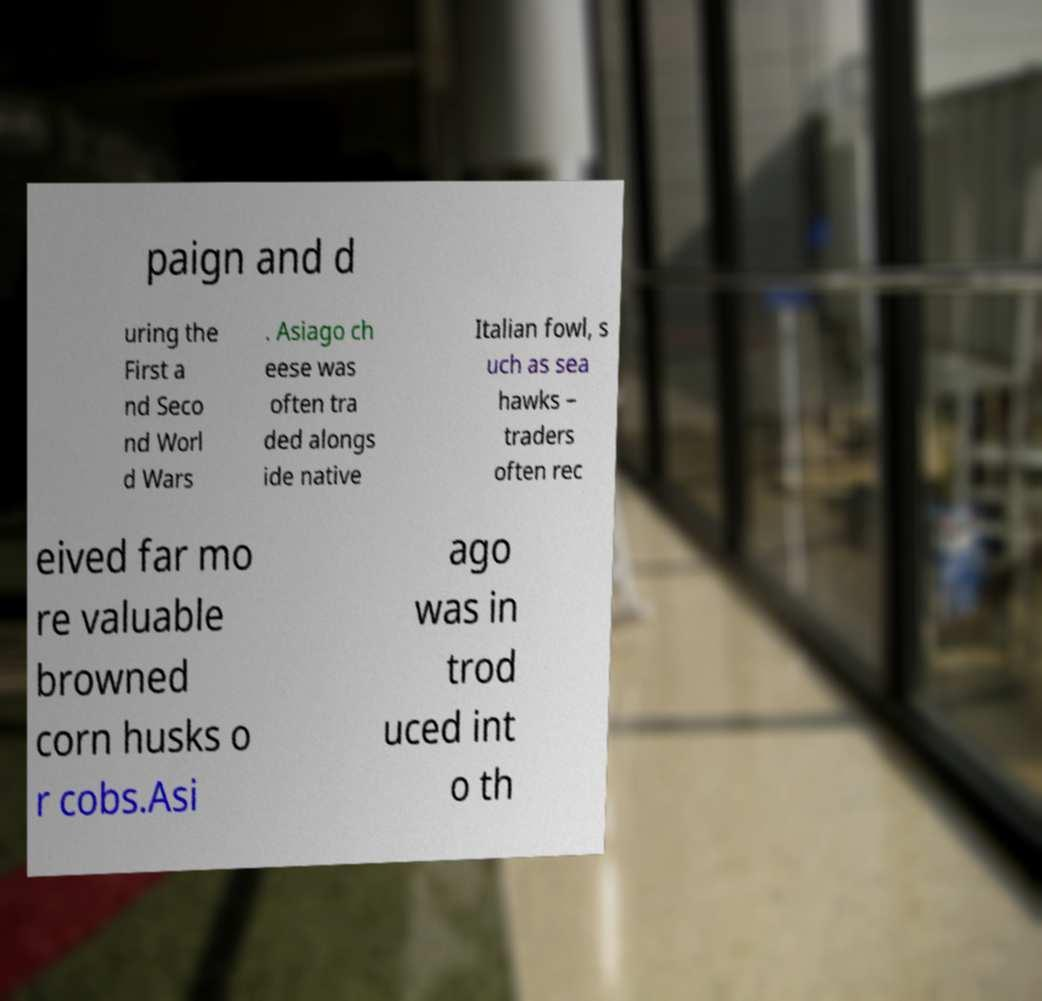Can you accurately transcribe the text from the provided image for me? paign and d uring the First a nd Seco nd Worl d Wars . Asiago ch eese was often tra ded alongs ide native Italian fowl, s uch as sea hawks – traders often rec eived far mo re valuable browned corn husks o r cobs.Asi ago was in trod uced int o th 